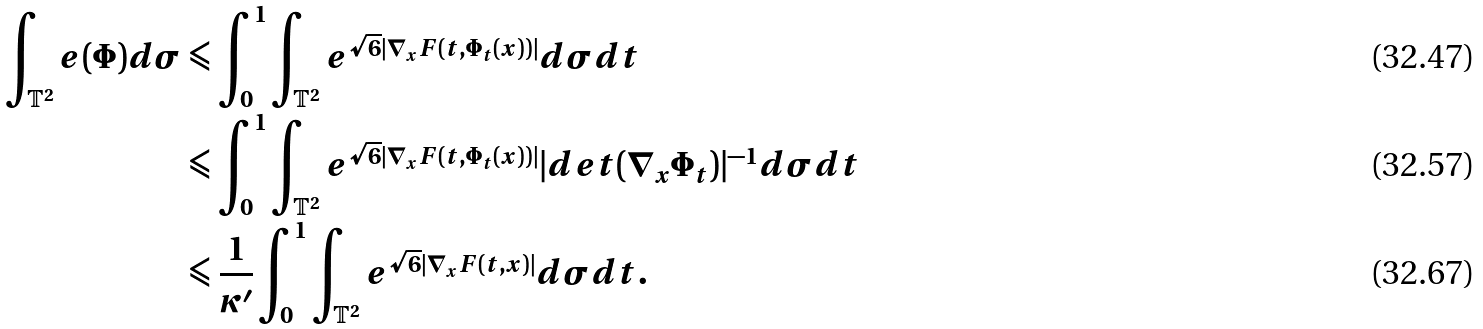<formula> <loc_0><loc_0><loc_500><loc_500>\int _ { \mathbb { T } ^ { 2 } } e ( \Phi ) d \sigma & \leqslant \int _ { 0 } ^ { 1 } \int _ { \mathbb { T } ^ { 2 } } e ^ { \sqrt { 6 } | \nabla _ { x } F ( t , \Phi _ { t } ( x ) ) | } d \sigma d t \\ & \leqslant \int _ { 0 } ^ { 1 } \int _ { \mathbb { T } ^ { 2 } } e ^ { \sqrt { 6 } | \nabla _ { x } F ( t , \Phi _ { t } ( x ) ) | } | d e t ( \nabla _ { x } \Phi _ { t } ) | ^ { - 1 } d \sigma d t \\ & \leqslant \frac { 1 } { \kappa ^ { \prime } } \int _ { 0 } ^ { 1 } \int _ { \mathbb { T } ^ { 2 } } e ^ { \sqrt { 6 } | \nabla _ { x } F ( t , x ) | } d \sigma d t .</formula> 